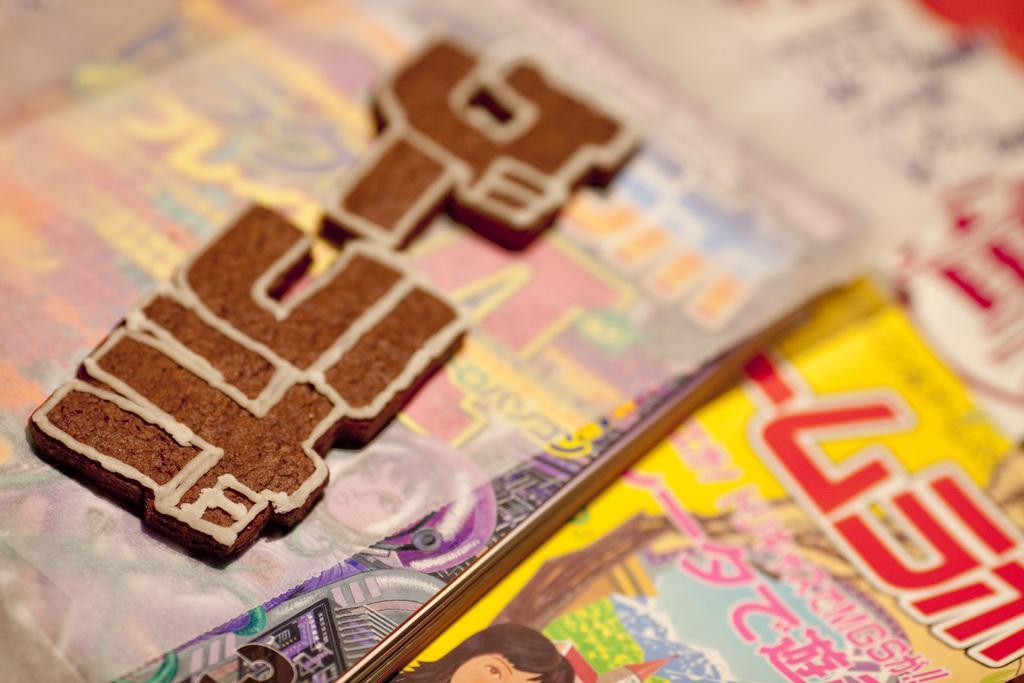Describe this image in one or two sentences. In this picture we can see some books where, there is a paper here. 